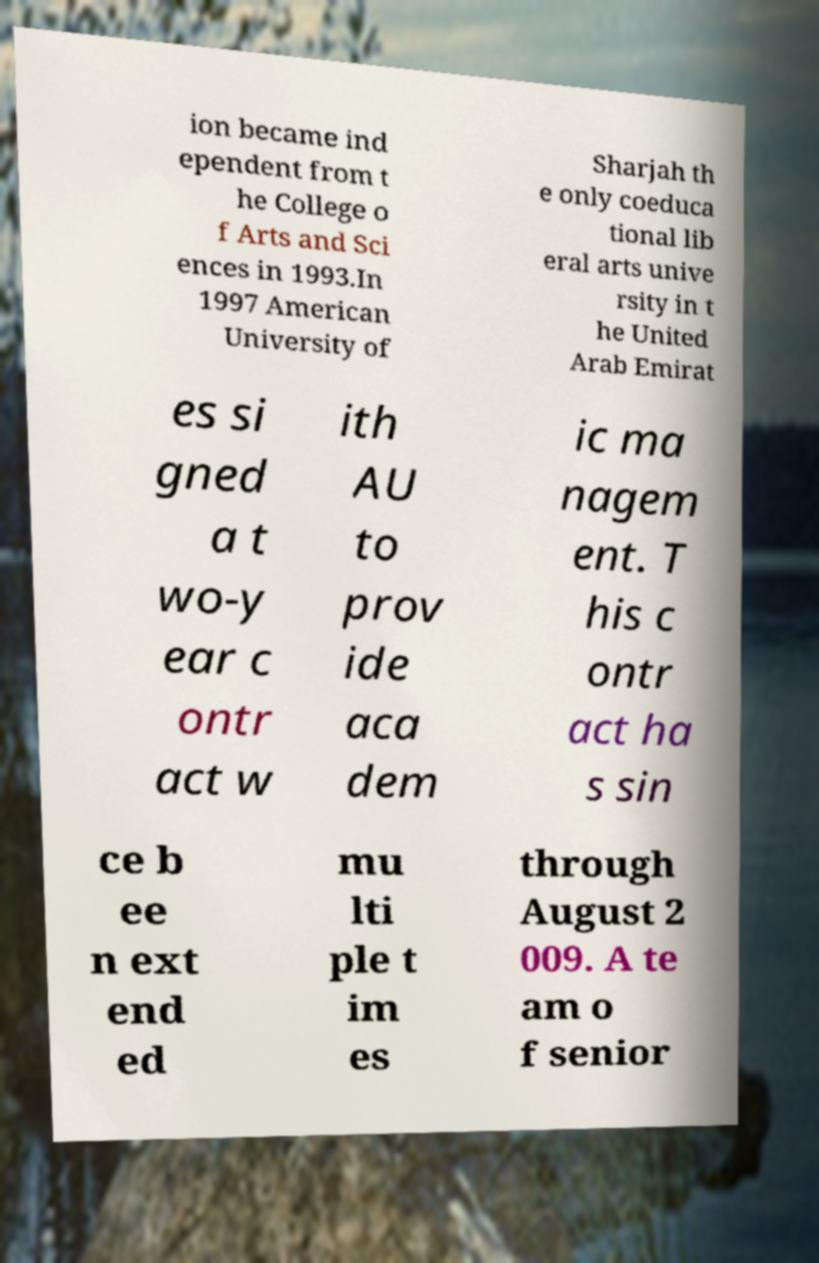I need the written content from this picture converted into text. Can you do that? ion became ind ependent from t he College o f Arts and Sci ences in 1993.In 1997 American University of Sharjah th e only coeduca tional lib eral arts unive rsity in t he United Arab Emirat es si gned a t wo-y ear c ontr act w ith AU to prov ide aca dem ic ma nagem ent. T his c ontr act ha s sin ce b ee n ext end ed mu lti ple t im es through August 2 009. A te am o f senior 